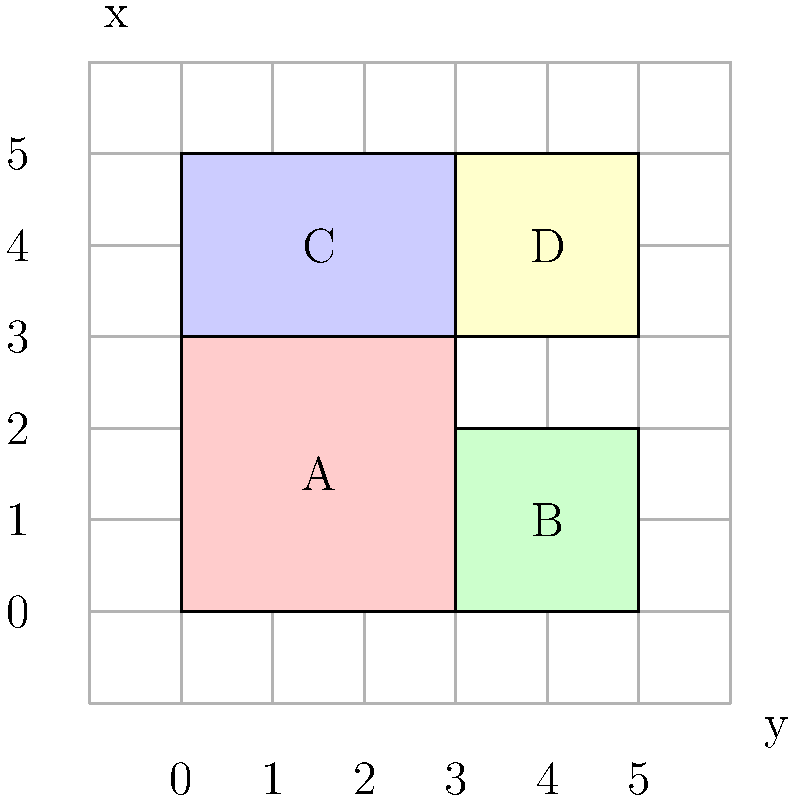In the coordinate grid system shown above, four voting districts (A, B, C, and D) are represented. If a new polling station is to be placed at coordinates (4, 4), which voting district will it belong to? To determine which voting district the new polling station will belong to, we need to follow these steps:

1. Identify the coordinates of the new polling station: (4, 4)

2. Examine the boundaries of each voting district:
   - District A: (0,0) to (3,3)
   - District B: (3,0) to (5,2)
   - District C: (0,3) to (3,5)
   - District D: (3,3) to (5,5)

3. Compare the coordinates (4, 4) with the boundaries of each district:
   - It's not in A because both x and y are greater than 3
   - It's not in B because y is greater than 2
   - It's not in C because x is greater than 3
   - It is within D because x is between 3 and 5, and y is between 3 and 5

4. Conclude that the point (4, 4) falls within the boundaries of District D

Therefore, the new polling station at coordinates (4, 4) will belong to voting district D.
Answer: D 